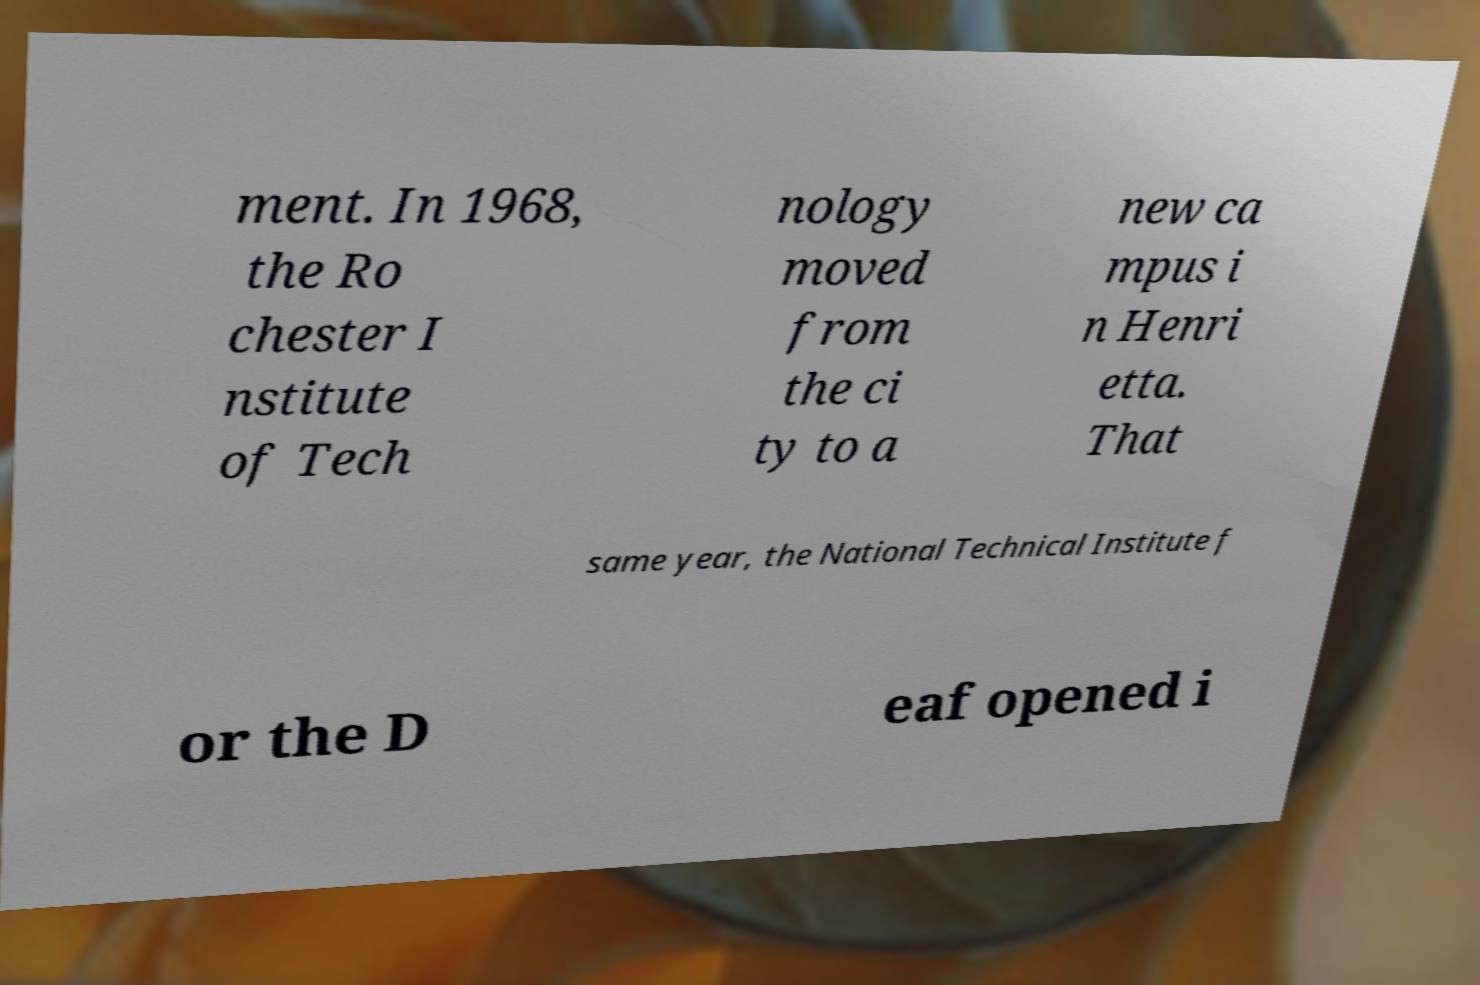What messages or text are displayed in this image? I need them in a readable, typed format. ment. In 1968, the Ro chester I nstitute of Tech nology moved from the ci ty to a new ca mpus i n Henri etta. That same year, the National Technical Institute f or the D eaf opened i 